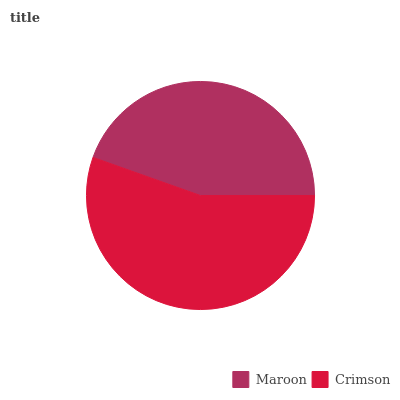Is Maroon the minimum?
Answer yes or no. Yes. Is Crimson the maximum?
Answer yes or no. Yes. Is Crimson the minimum?
Answer yes or no. No. Is Crimson greater than Maroon?
Answer yes or no. Yes. Is Maroon less than Crimson?
Answer yes or no. Yes. Is Maroon greater than Crimson?
Answer yes or no. No. Is Crimson less than Maroon?
Answer yes or no. No. Is Crimson the high median?
Answer yes or no. Yes. Is Maroon the low median?
Answer yes or no. Yes. Is Maroon the high median?
Answer yes or no. No. Is Crimson the low median?
Answer yes or no. No. 